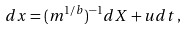Convert formula to latex. <formula><loc_0><loc_0><loc_500><loc_500>d x = ( m ^ { 1 / b } ) ^ { - 1 } d X + u d t \, ,</formula> 